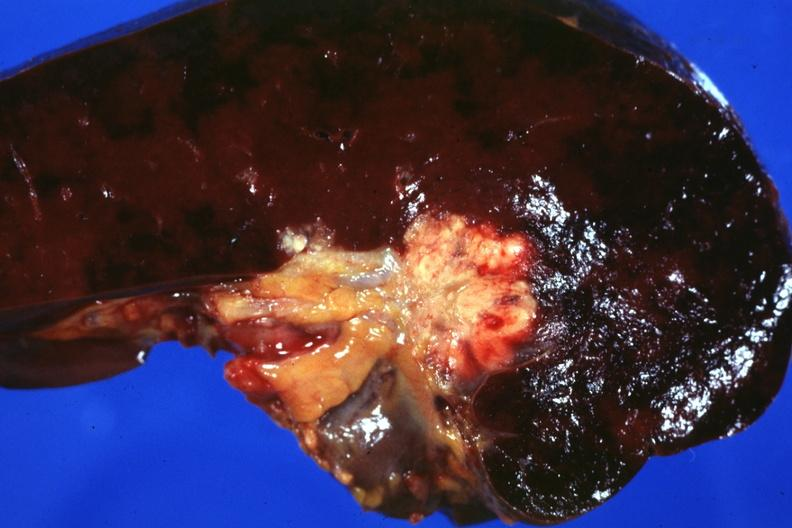s normal palmar creases spread into the spleen in this case?
Answer the question using a single word or phrase. No 